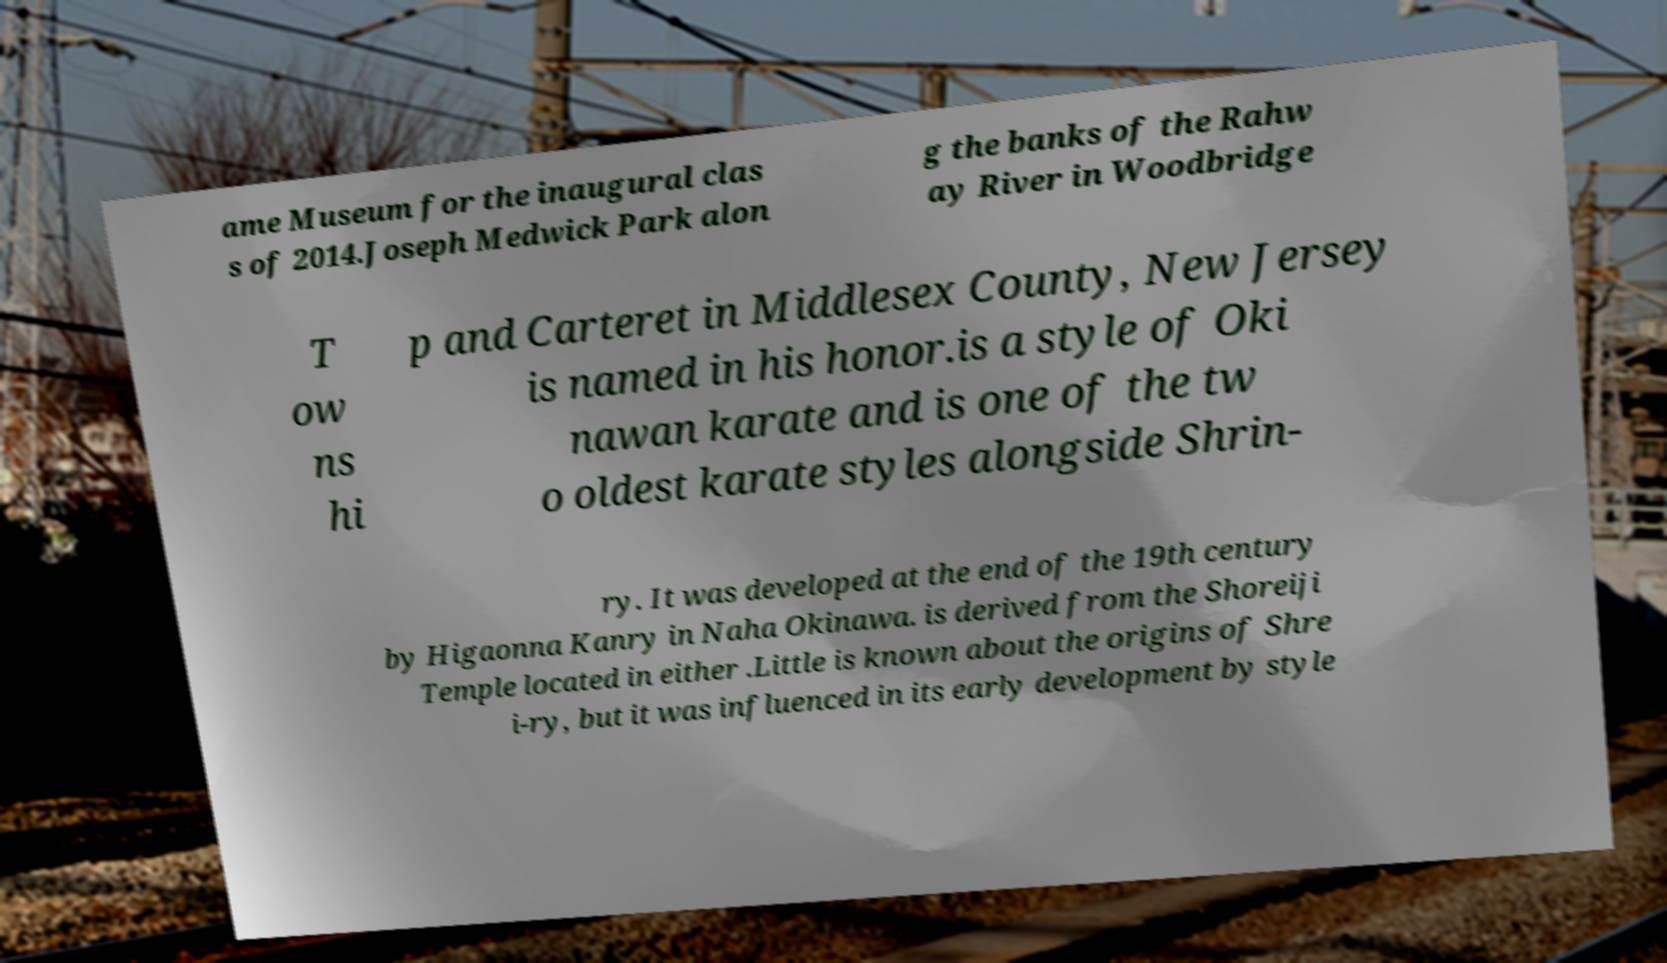I need the written content from this picture converted into text. Can you do that? ame Museum for the inaugural clas s of 2014.Joseph Medwick Park alon g the banks of the Rahw ay River in Woodbridge T ow ns hi p and Carteret in Middlesex County, New Jersey is named in his honor.is a style of Oki nawan karate and is one of the tw o oldest karate styles alongside Shrin- ry. It was developed at the end of the 19th century by Higaonna Kanry in Naha Okinawa. is derived from the Shoreiji Temple located in either .Little is known about the origins of Shre i-ry, but it was influenced in its early development by style 